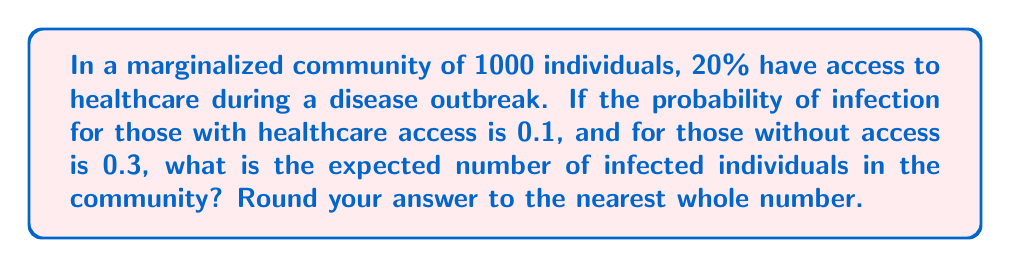What is the answer to this math problem? Let's break this down step-by-step:

1) First, let's identify the key information:
   - Total population: 1000
   - Percentage with healthcare access: 20%
   - Probability of infection with healthcare access: 0.1
   - Probability of infection without healthcare access: 0.3

2) Calculate the number of people with and without healthcare access:
   - With access: $1000 \times 20\% = 200$
   - Without access: $1000 - 200 = 800$

3) Calculate the expected number of infected individuals in each group:
   - For those with access:
     $E(\text{infected with access}) = 200 \times 0.1 = 20$
   
   - For those without access:
     $E(\text{infected without access}) = 800 \times 0.3 = 240$

4) Sum the expected number of infected individuals:
   $E(\text{total infected}) = E(\text{infected with access}) + E(\text{infected without access})$
   $E(\text{total infected}) = 20 + 240 = 260$

5) Round to the nearest whole number:
   260 (no rounding needed in this case)

The expected number of infected individuals can also be expressed using probability theory as:

$$E(\text{total infected}) = N(p_a \cdot P_a + p_n \cdot P_n)$$

Where:
$N$ is the total population
$p_a$ is the proportion with access
$P_a$ is the probability of infection with access
$p_n$ is the proportion without access
$P_n$ is the probability of infection without access

Plugging in our values:

$$E(\text{total infected}) = 1000(0.2 \cdot 0.1 + 0.8 \cdot 0.3) = 1000(0.02 + 0.24) = 1000(0.26) = 260$$

This confirms our step-by-step calculation.
Answer: 260 